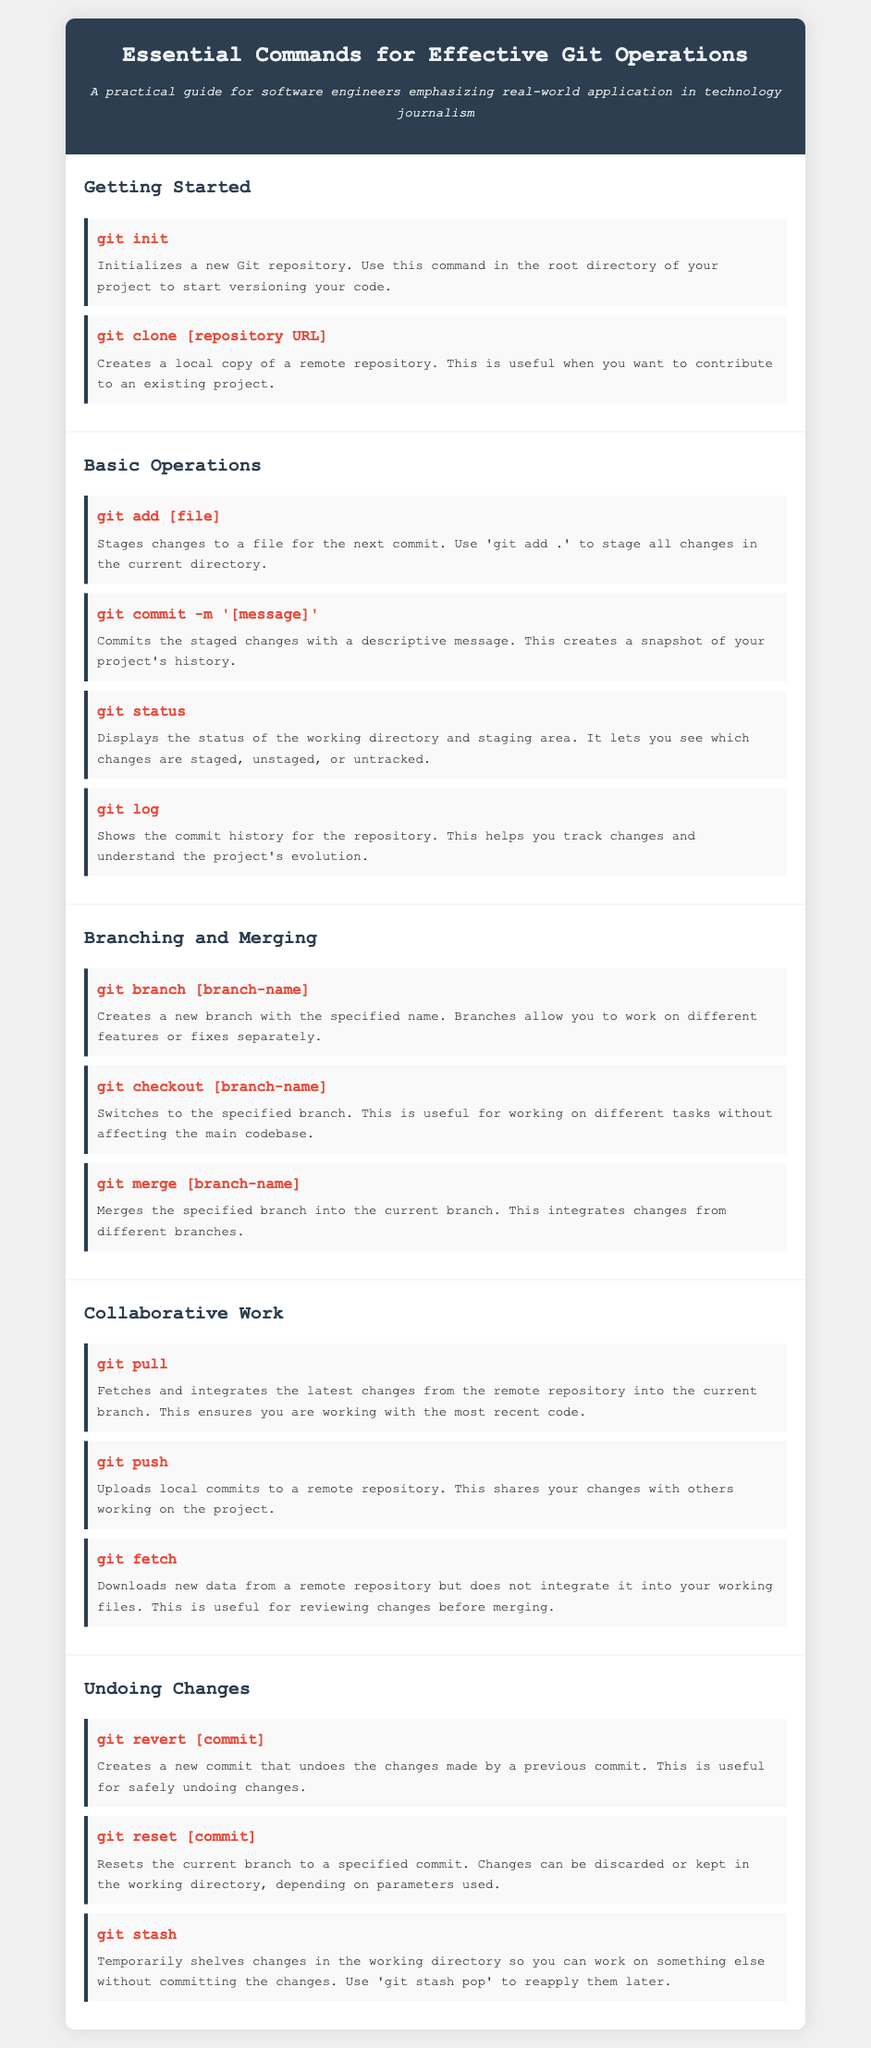What command initializes a new Git repository? The document states that "git init" initializes a new Git repository.
Answer: git init What command creates a local copy of a remote repository? According to the document, "git clone [repository URL]" creates a local copy of a remote repository.
Answer: git clone [repository URL] What does "git commit -m '[message]'" do? The document describes that this command commits the staged changes with a descriptive message.
Answer: Commits the staged changes How do you stage all changes in the current directory? The document specifies that "Use 'git add .' to stage all changes in the current directory."
Answer: git add  Which command merges a specified branch into the current branch? The document states that "git merge [branch-name]" merges the specified branch into the current branch.
Answer: git merge [branch-name] What is the purpose of the "git pull" command? The document explains that "git pull" fetches and integrates the latest changes from the remote repository into the current branch.
Answer: Fetches and integrates changes What command temporarily shelves changes in the working directory? The document indicates that "git stash" temporarily shelves changes in the working directory.
Answer: git stash Which section contains commands for collaborative work? In the document, the "Collaborative Work" section contains commands for collaborative work.
Answer: Collaborative Work How many commands are listed in the "Basic Operations" section? The document provides four commands in the "Basic Operations" section.
Answer: Four 